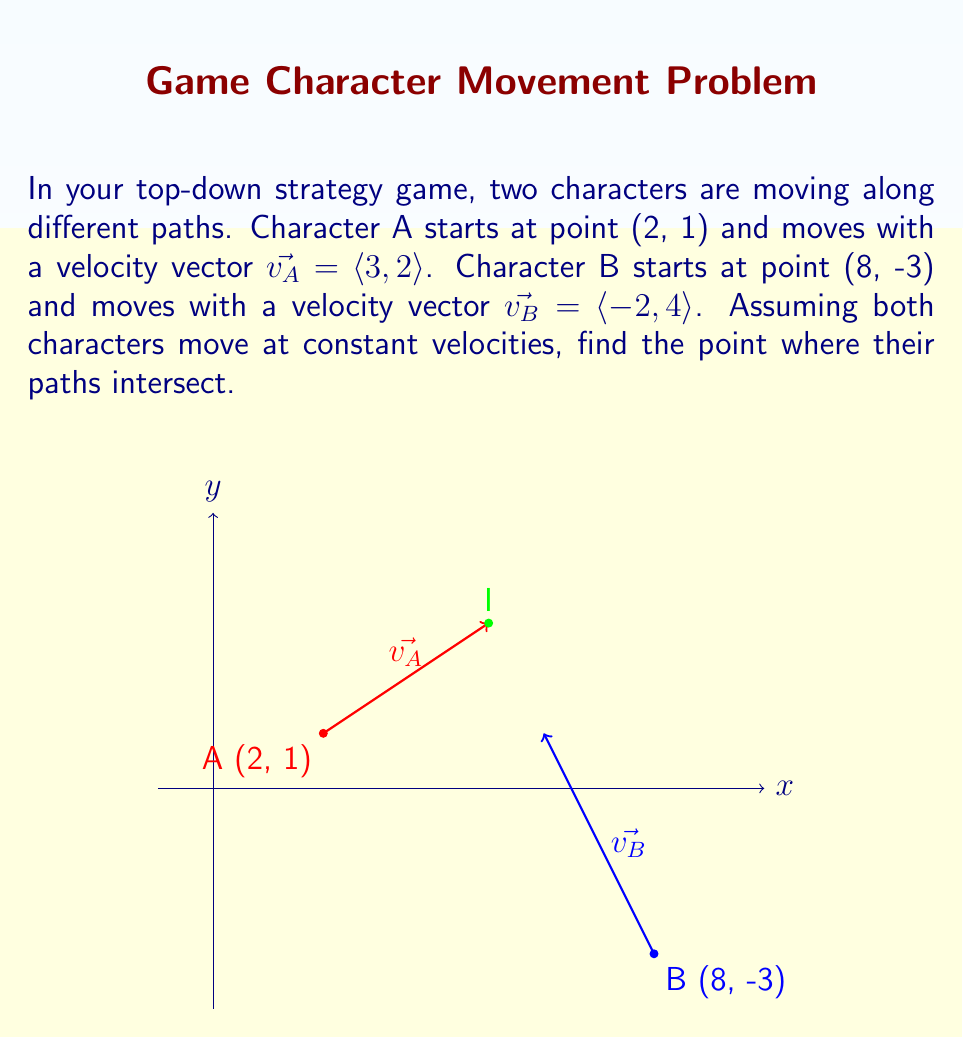Can you solve this math problem? Let's approach this step-by-step:

1) We can represent the position of each character at time $t$ using vector-valued functions:

   Character A: $\vec{r_A}(t) = \langle 2, 1 \rangle + t\langle 3, 2 \rangle = \langle 2+3t, 1+2t \rangle$
   Character B: $\vec{r_B}(t) = \langle 8, -3 \rangle + t\langle -2, 4 \rangle = \langle 8-2t, -3+4t \rangle$

2) At the intersection point, these position vectors will be equal. So we can set up the equation:

   $\vec{r_A}(t_1) = \vec{r_B}(t_2)$

3) This gives us two equations:

   $2 + 3t_1 = 8 - 2t_2$
   $1 + 2t_1 = -3 + 4t_2$

4) Solve the first equation for $t_1$:

   $t_1 = 2 - \frac{2}{3}t_2$

5) Substitute this into the second equation:

   $1 + 2(2 - \frac{2}{3}t_2) = -3 + 4t_2$
   $5 - \frac{4}{3}t_2 = -3 + 4t_2$
   $8 = \frac{16}{3}t_2$
   $t_2 = \frac{3}{2}$

6) Now we can find $t_1$:

   $t_1 = 2 - \frac{2}{3}(\frac{3}{2}) = 1$

7) We can use either $t_1$ or $t_2$ in their respective position functions to find the intersection point:

   $\vec{r_A}(1) = \langle 2+3(1), 1+2(1) \rangle = \langle 5, 3 \rangle$
   
   or
   
   $\vec{r_B}(\frac{3}{2}) = \langle 8-2(\frac{3}{2}), -3+4(\frac{3}{2}) \rangle = \langle 5, 3 \rangle$
Answer: (5, 3) 